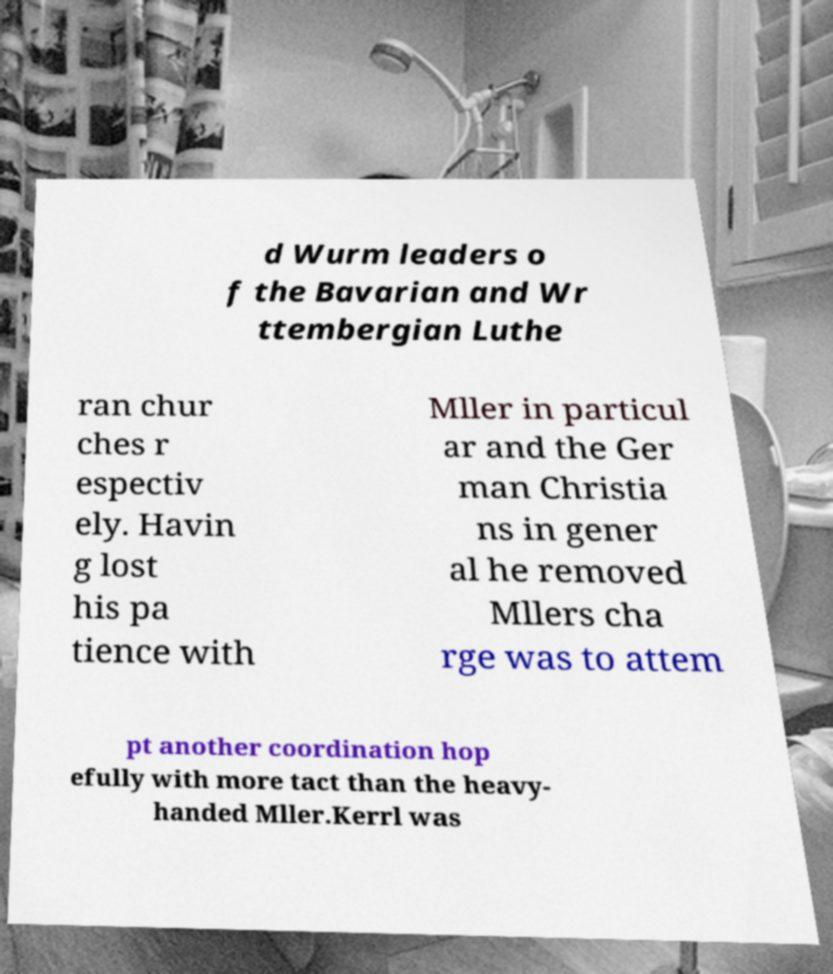I need the written content from this picture converted into text. Can you do that? d Wurm leaders o f the Bavarian and Wr ttembergian Luthe ran chur ches r espectiv ely. Havin g lost his pa tience with Mller in particul ar and the Ger man Christia ns in gener al he removed Mllers cha rge was to attem pt another coordination hop efully with more tact than the heavy- handed Mller.Kerrl was 